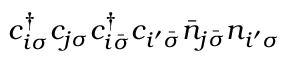Convert formula to latex. <formula><loc_0><loc_0><loc_500><loc_500>c _ { i \sigma } ^ { \dagger } c _ { j \sigma } c _ { i \bar { \sigma } } ^ { \dagger } c _ { i ^ { \prime } \bar { \sigma } } \bar { n } _ { j \bar { \sigma } } n _ { i ^ { \prime } \sigma }</formula> 